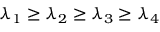Convert formula to latex. <formula><loc_0><loc_0><loc_500><loc_500>\lambda _ { 1 } \geq \lambda _ { 2 } \geq \lambda _ { 3 } \geq \lambda _ { 4 }</formula> 